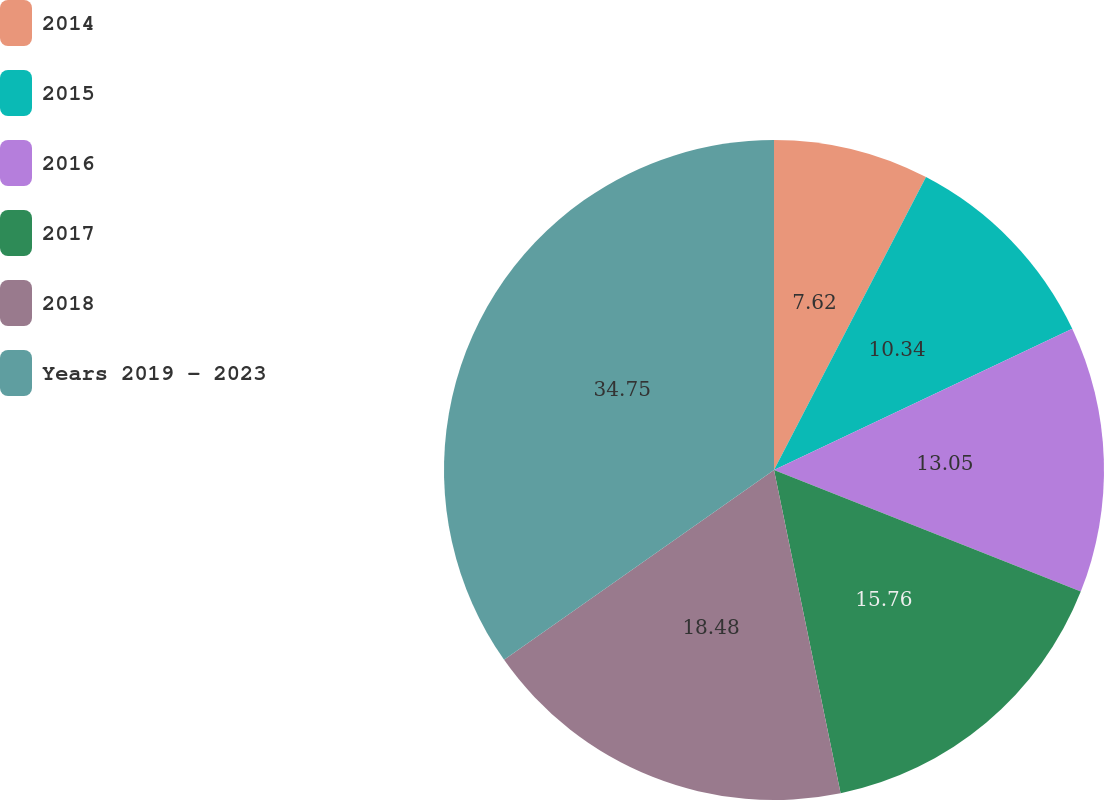<chart> <loc_0><loc_0><loc_500><loc_500><pie_chart><fcel>2014<fcel>2015<fcel>2016<fcel>2017<fcel>2018<fcel>Years 2019 - 2023<nl><fcel>7.62%<fcel>10.34%<fcel>13.05%<fcel>15.76%<fcel>18.48%<fcel>34.76%<nl></chart> 